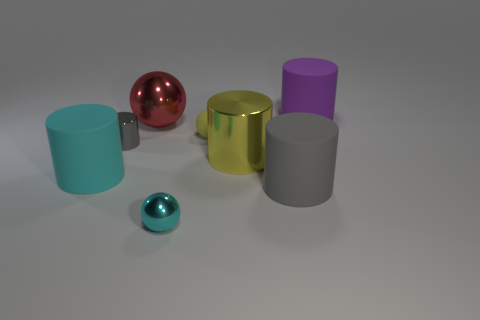How big is the gray cylinder that is on the left side of the big metal object that is to the left of the tiny rubber thing?
Your answer should be very brief. Small. Are the cyan cylinder and the thing in front of the gray matte object made of the same material?
Offer a very short reply. No. Are there fewer small rubber objects that are behind the yellow matte ball than small gray cylinders behind the purple matte thing?
Your response must be concise. No. The large cylinder that is made of the same material as the red thing is what color?
Give a very brief answer. Yellow. There is a cyan object that is behind the small shiny ball; is there a tiny object to the left of it?
Offer a terse response. No. The shiny ball that is the same size as the yellow metallic object is what color?
Your answer should be compact. Red. How many things are either large cyan things or balls?
Make the answer very short. 4. How big is the thing that is on the right side of the rubber cylinder in front of the large rubber cylinder that is left of the tiny gray shiny cylinder?
Provide a short and direct response. Large. What number of large cylinders have the same color as the big sphere?
Your answer should be compact. 0. What number of big cylinders have the same material as the cyan sphere?
Offer a terse response. 1. 